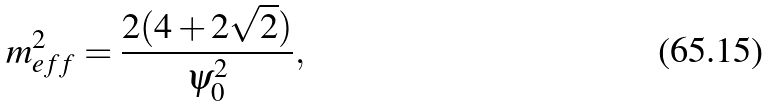<formula> <loc_0><loc_0><loc_500><loc_500>m ^ { 2 } _ { e f f } = \frac { 2 ( 4 + 2 \sqrt { 2 } ) } { \psi ^ { 2 } _ { 0 } } ,</formula> 